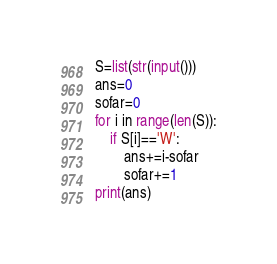<code> <loc_0><loc_0><loc_500><loc_500><_Python_>S=list(str(input()))
ans=0
sofar=0
for i in range(len(S)):
    if S[i]=='W':
        ans+=i-sofar
        sofar+=1
print(ans)</code> 